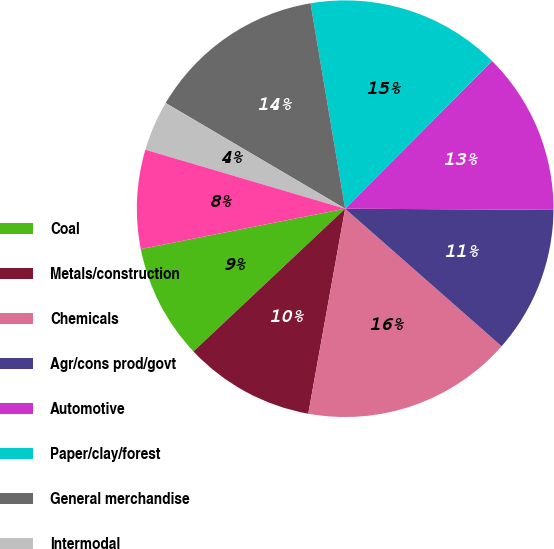Convert chart. <chart><loc_0><loc_0><loc_500><loc_500><pie_chart><fcel>Coal<fcel>Metals/construction<fcel>Chemicals<fcel>Agr/cons prod/govt<fcel>Automotive<fcel>Paper/clay/forest<fcel>General merchandise<fcel>Intermodal<fcel>Total<nl><fcel>8.91%<fcel>10.15%<fcel>16.35%<fcel>11.39%<fcel>12.63%<fcel>15.11%<fcel>13.87%<fcel>3.9%<fcel>7.67%<nl></chart> 